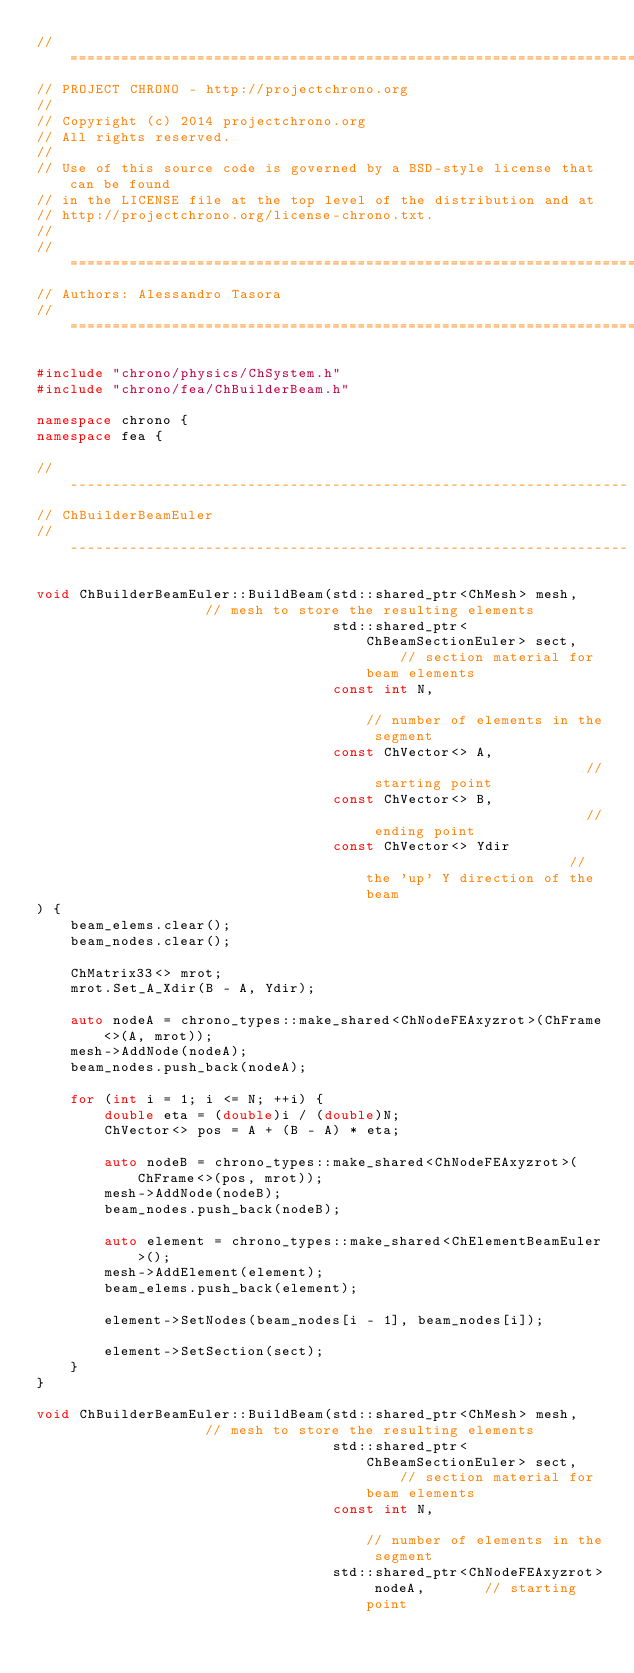<code> <loc_0><loc_0><loc_500><loc_500><_C++_>// =============================================================================
// PROJECT CHRONO - http://projectchrono.org
//
// Copyright (c) 2014 projectchrono.org
// All rights reserved.
//
// Use of this source code is governed by a BSD-style license that can be found
// in the LICENSE file at the top level of the distribution and at
// http://projectchrono.org/license-chrono.txt.
//
// =============================================================================
// Authors: Alessandro Tasora
// =============================================================================

#include "chrono/physics/ChSystem.h"
#include "chrono/fea/ChBuilderBeam.h"

namespace chrono {
namespace fea {

// ------------------------------------------------------------------
// ChBuilderBeamEuler
// ------------------------------------------------------------------

void ChBuilderBeamEuler::BuildBeam(std::shared_ptr<ChMesh> mesh,                 // mesh to store the resulting elements
                                   std::shared_ptr<ChBeamSectionEuler> sect,     // section material for beam elements
                                   const int N,                                  // number of elements in the segment
                                   const ChVector<> A,                           // starting point
                                   const ChVector<> B,                           // ending point
                                   const ChVector<> Ydir                         // the 'up' Y direction of the beam
) {
    beam_elems.clear();
    beam_nodes.clear();

    ChMatrix33<> mrot;
    mrot.Set_A_Xdir(B - A, Ydir);

    auto nodeA = chrono_types::make_shared<ChNodeFEAxyzrot>(ChFrame<>(A, mrot));
    mesh->AddNode(nodeA);
    beam_nodes.push_back(nodeA);

    for (int i = 1; i <= N; ++i) {
        double eta = (double)i / (double)N;
        ChVector<> pos = A + (B - A) * eta;

        auto nodeB = chrono_types::make_shared<ChNodeFEAxyzrot>(ChFrame<>(pos, mrot));
        mesh->AddNode(nodeB);
        beam_nodes.push_back(nodeB);

        auto element = chrono_types::make_shared<ChElementBeamEuler>();
        mesh->AddElement(element);
        beam_elems.push_back(element);

        element->SetNodes(beam_nodes[i - 1], beam_nodes[i]);

        element->SetSection(sect);
    }
}

void ChBuilderBeamEuler::BuildBeam(std::shared_ptr<ChMesh> mesh,                 // mesh to store the resulting elements
                                   std::shared_ptr<ChBeamSectionEuler> sect,     // section material for beam elements
                                   const int N,                                  // number of elements in the segment
                                   std::shared_ptr<ChNodeFEAxyzrot> nodeA,       // starting point</code> 